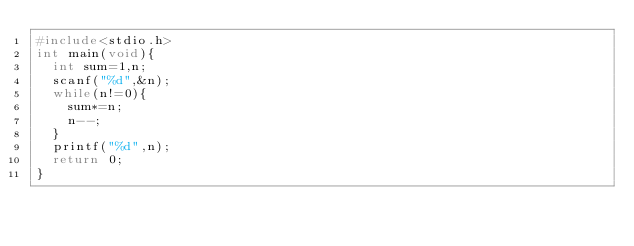Convert code to text. <code><loc_0><loc_0><loc_500><loc_500><_C_>#include<stdio.h>
int main(void){
  int sum=1,n;
  scanf("%d",&n);
  while(n!=0){
    sum*=n;
    n--;
  }
  printf("%d",n);
  return 0;
}</code> 